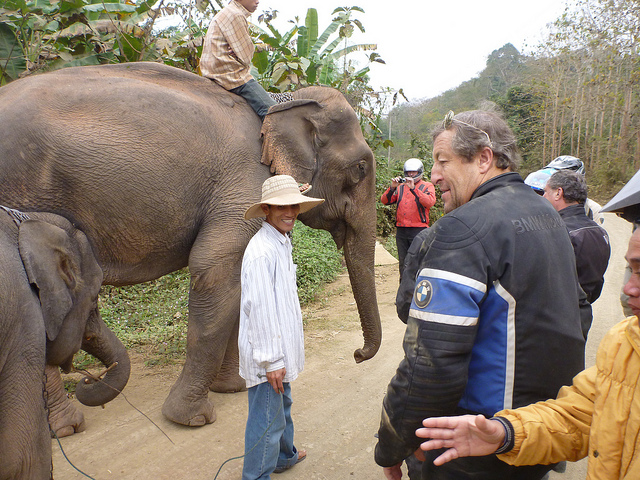<image>What circus do these animals belong to? I don't know what circus these animals belong to. It could be 'shrine', 'barnum and bailey' or 'indian', or even none. What circus do these animals belong to? I am not sure what circus these animals belong to. They can be from 'shrine', 'barnum and bailey', or 'indian'. 